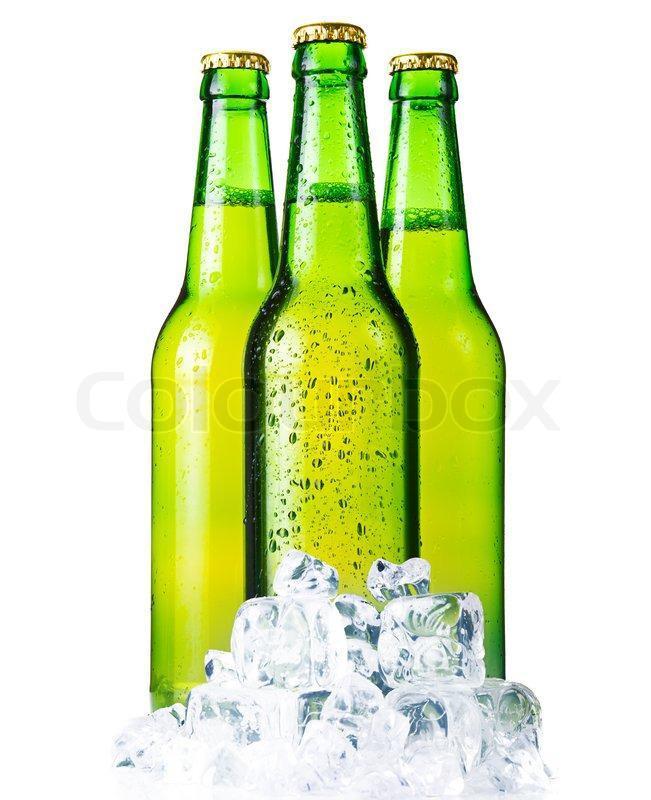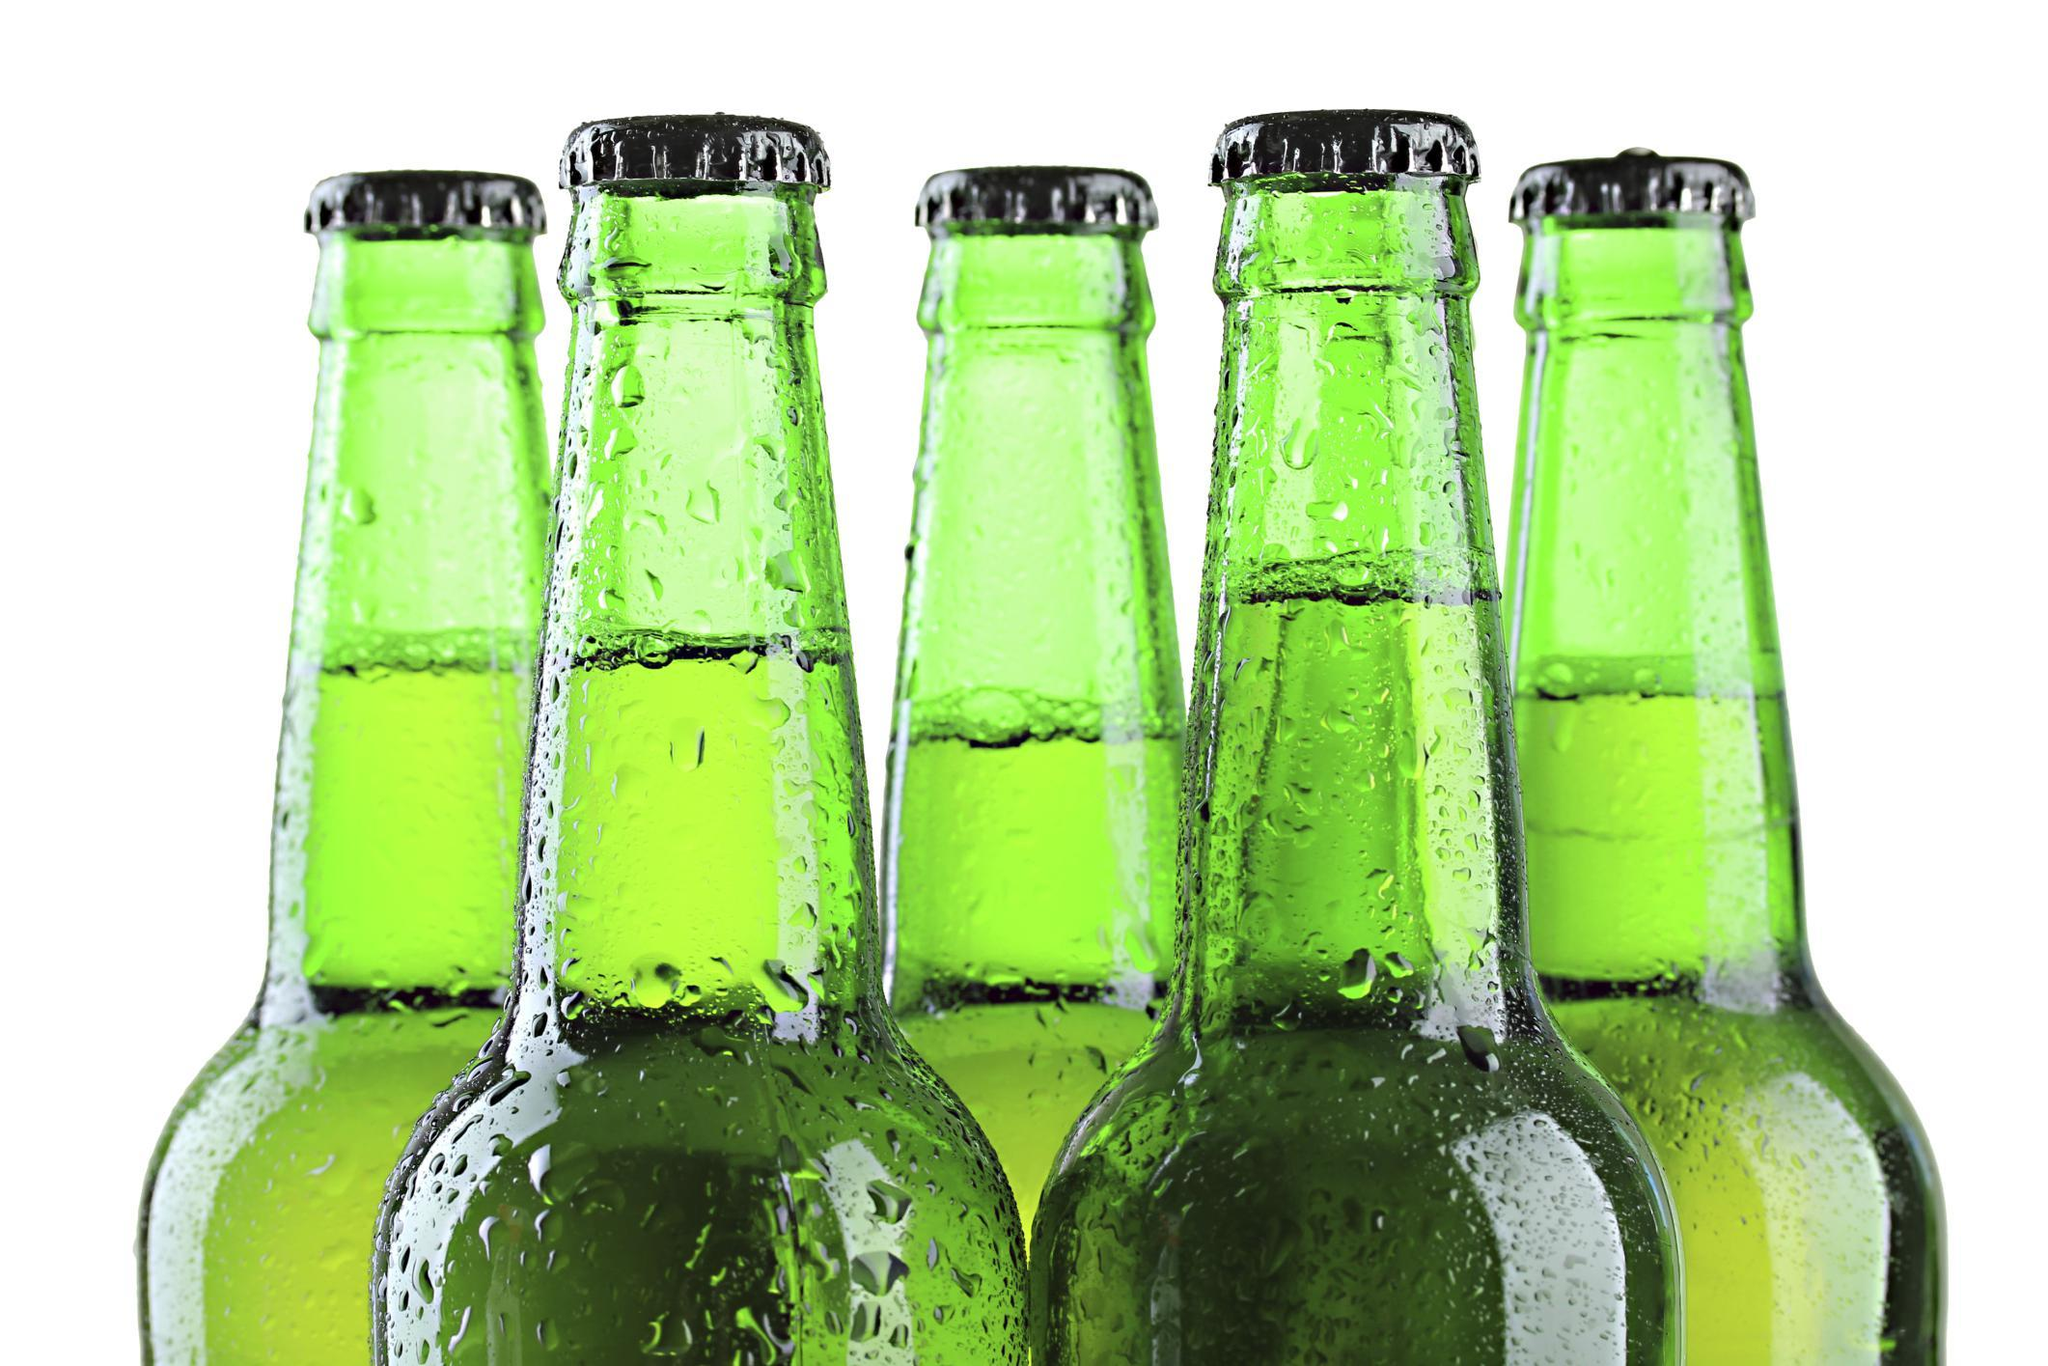The first image is the image on the left, the second image is the image on the right. Considering the images on both sides, is "There are no more than six glass bottles" valid? Answer yes or no. No. 